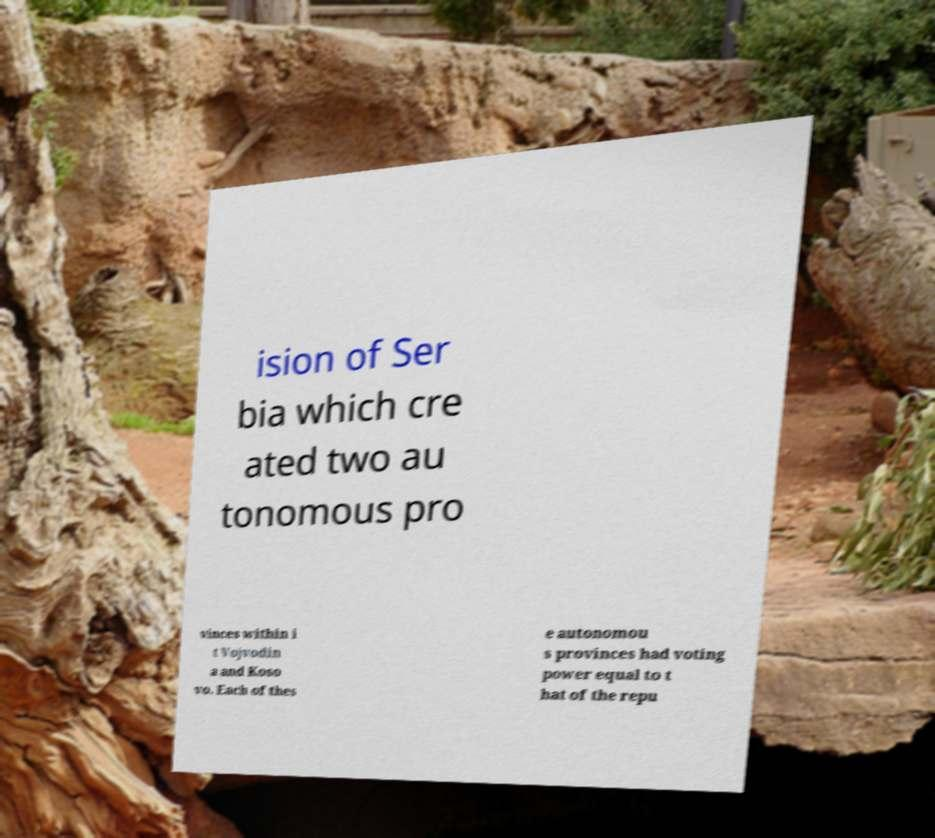Could you extract and type out the text from this image? ision of Ser bia which cre ated two au tonomous pro vinces within i t Vojvodin a and Koso vo. Each of thes e autonomou s provinces had voting power equal to t hat of the repu 